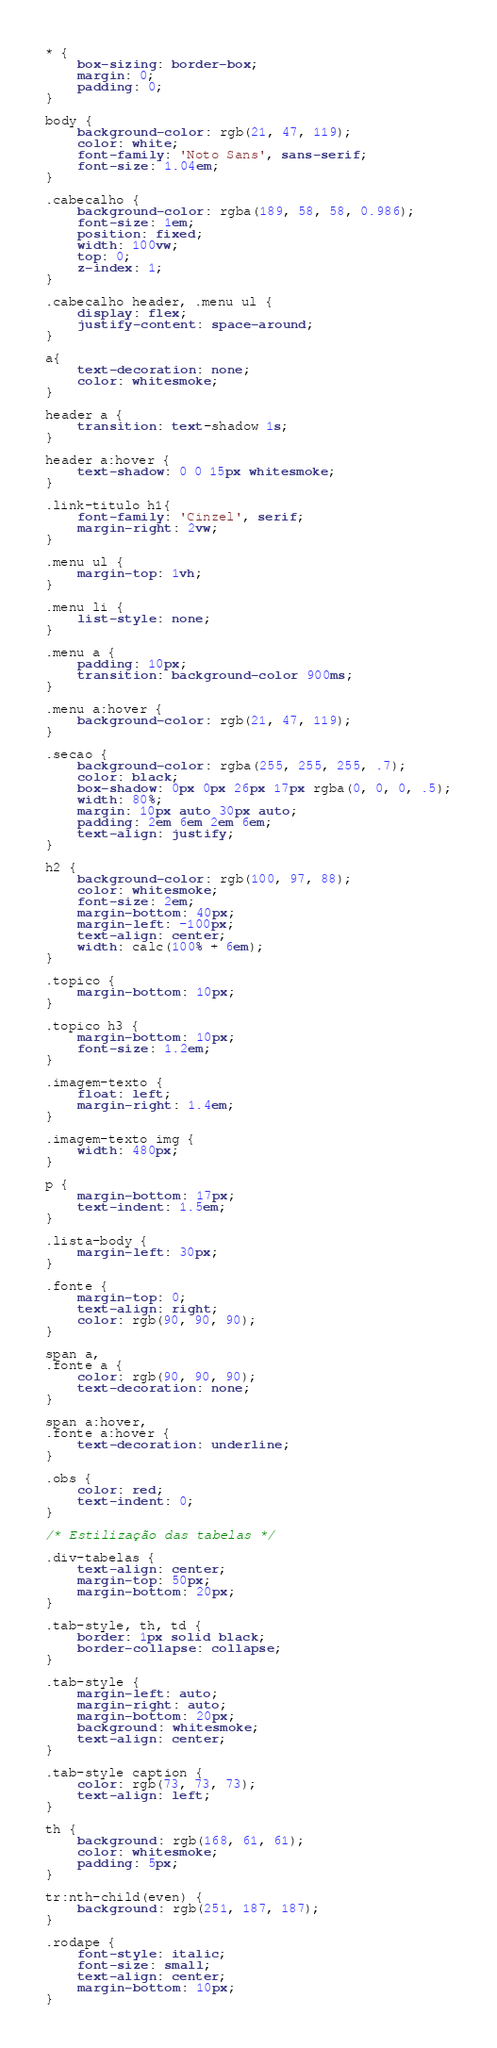<code> <loc_0><loc_0><loc_500><loc_500><_CSS_>* {
    box-sizing: border-box;
    margin: 0;
    padding: 0;
}

body {
    background-color: rgb(21, 47, 119);
    color: white;
    font-family: 'Noto Sans', sans-serif;
    font-size: 1.04em;
}    

.cabecalho {
    background-color: rgba(189, 58, 58, 0.986);
    font-size: 1em;
    position: fixed;
    width: 100vw;
    top: 0;
    z-index: 1;
}

.cabecalho header, .menu ul {
    display: flex;
    justify-content: space-around;
}

a{
    text-decoration: none;
    color: whitesmoke;
}

header a {
    transition: text-shadow 1s;
}

header a:hover {
    text-shadow: 0 0 15px whitesmoke;
}

.link-titulo h1{
    font-family: 'Cinzel', serif;
    margin-right: 2vw;
}

.menu ul {
    margin-top: 1vh;
}

.menu li {
    list-style: none;
}

.menu a {
    padding: 10px;
    transition: background-color 900ms;
}

.menu a:hover {
    background-color: rgb(21, 47, 119);
}

.secao {
    background-color: rgba(255, 255, 255, .7);
    color: black;
    box-shadow: 0px 0px 26px 17px rgba(0, 0, 0, .5);
    width: 80%;
    margin: 10px auto 30px auto;
    padding: 2em 6em 2em 6em;
    text-align: justify;
}

h2 {
    background-color: rgb(100, 97, 88);
    color: whitesmoke;
    font-size: 2em;
    margin-bottom: 40px;
    margin-left: -100px;
    text-align: center;
    width: calc(100% + 6em);
}

.topico {
    margin-bottom: 10px;
}

.topico h3 {
    margin-bottom: 10px;
    font-size: 1.2em;
}

.imagem-texto {
    float: left;
    margin-right: 1.4em;
}

.imagem-texto img {
    width: 480px;
}

p {
    margin-bottom: 17px;
    text-indent: 1.5em;
}

.lista-body {
    margin-left: 30px;
}

.fonte {
    margin-top: 0;
    text-align: right;
    color: rgb(90, 90, 90);
}

span a,
.fonte a {
    color: rgb(90, 90, 90);
    text-decoration: none;
}

span a:hover,
.fonte a:hover {
    text-decoration: underline;
}

.obs {
    color: red;
    text-indent: 0;
}

/* Estilização das tabelas */

.div-tabelas {
    text-align: center;
    margin-top: 50px;
    margin-bottom: 20px;
}

.tab-style, th, td {
    border: 1px solid black;
    border-collapse: collapse;
}   

.tab-style {
    margin-left: auto;
    margin-right: auto;
    margin-bottom: 20px;
    background: whitesmoke;  
    text-align: center;
}

.tab-style caption {
    color: rgb(73, 73, 73);
    text-align: left;
}

th {
    background: rgb(168, 61, 61);
    color: whitesmoke;
    padding: 5px;
}

tr:nth-child(even) {
    background: rgb(251, 187, 187);
}

.rodape {
    font-style: italic;
    font-size: small;
    text-align: center;
    margin-bottom: 10px;
}</code> 